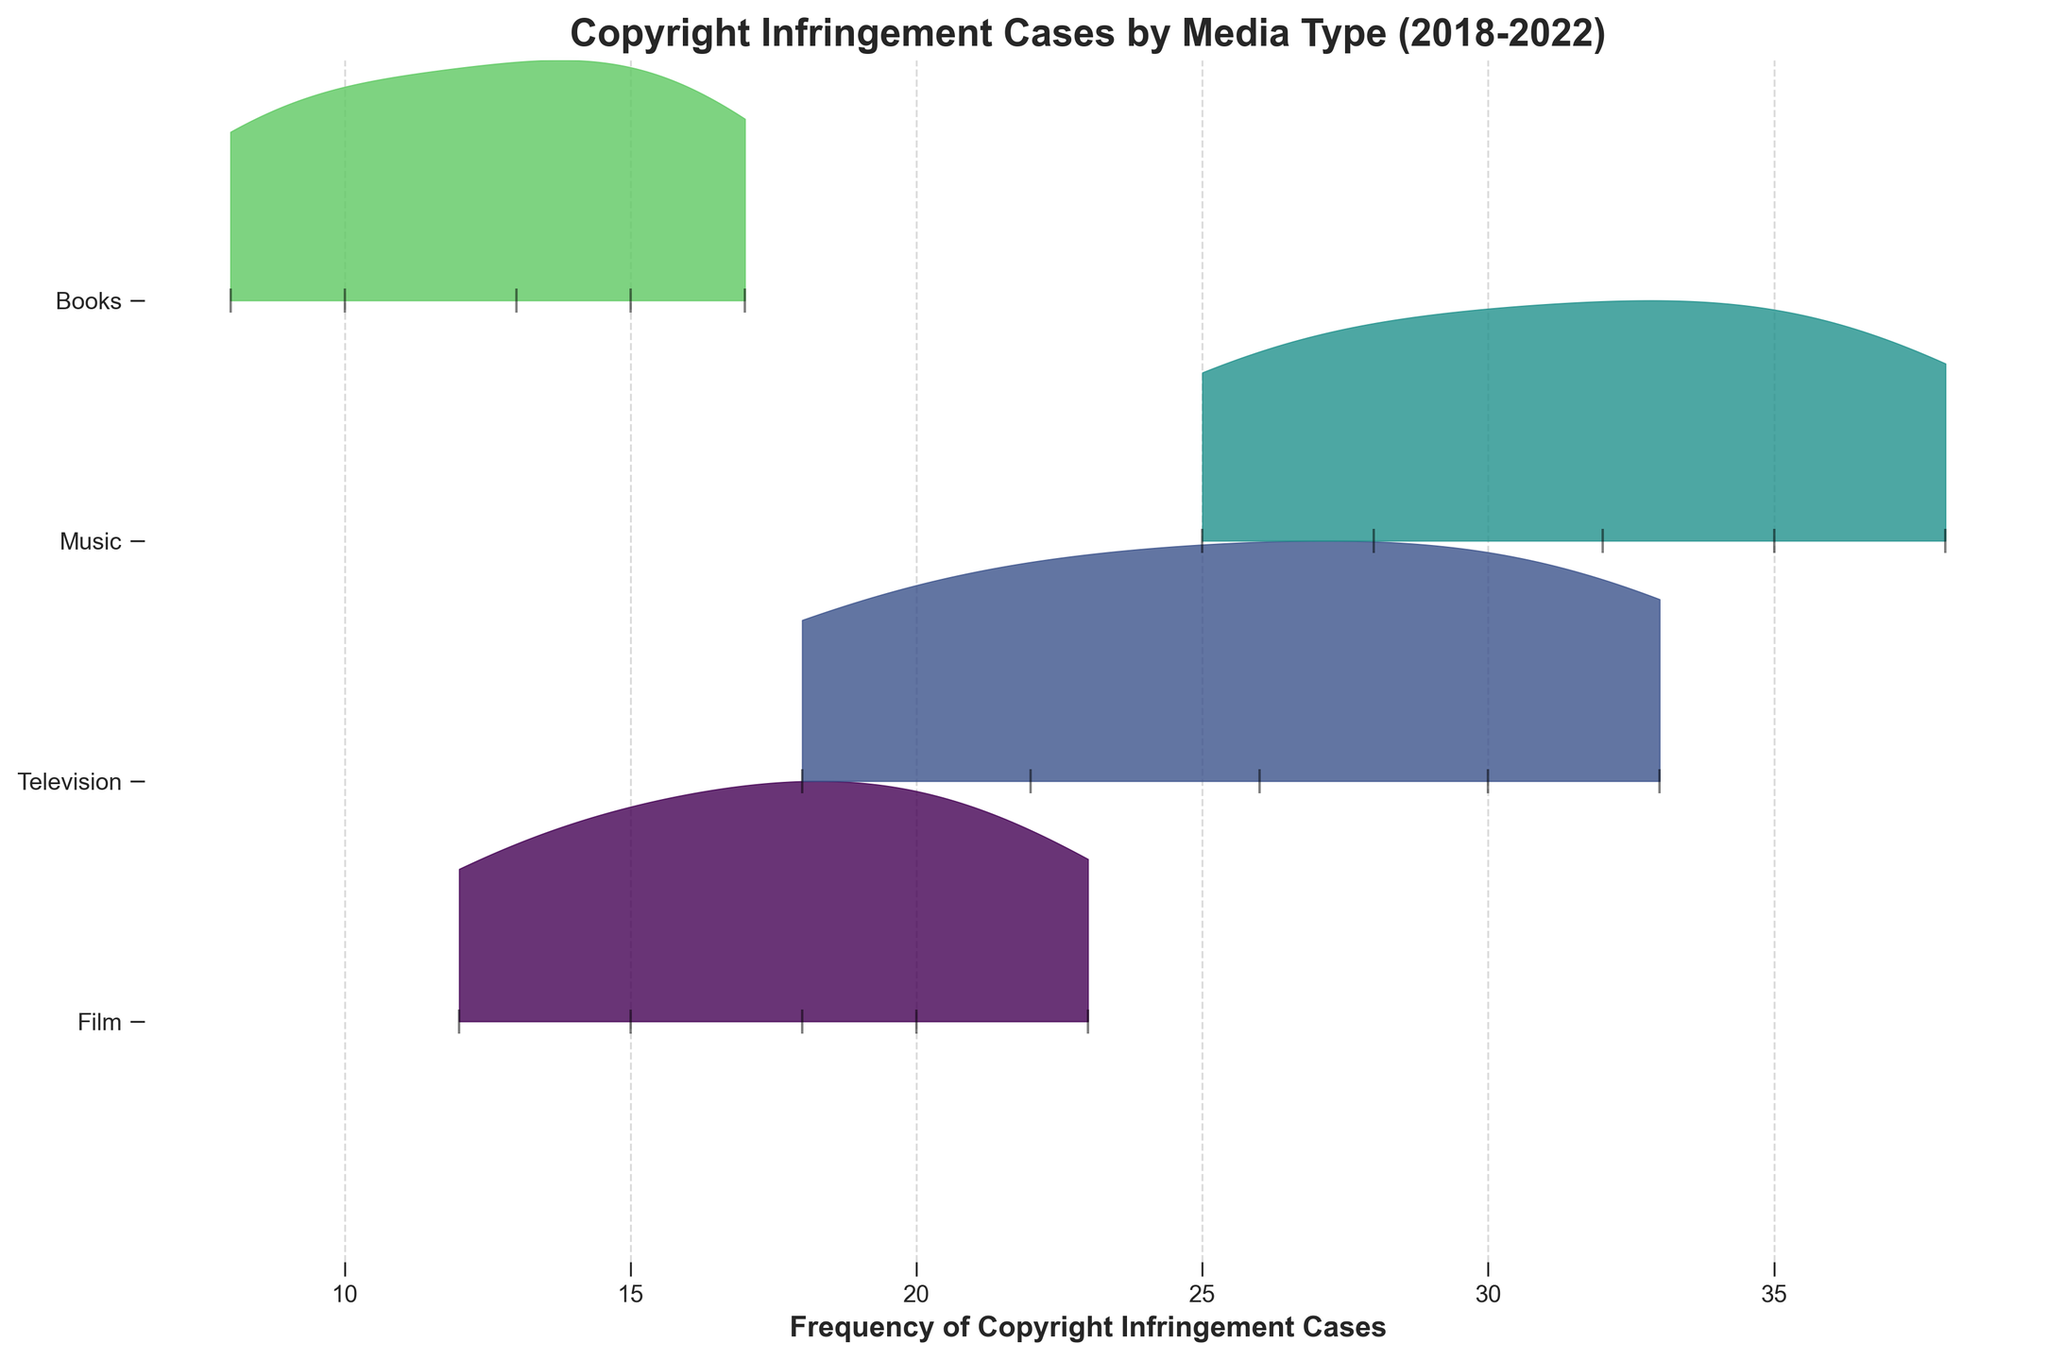How many different media types are represented in the plot? The title and axes labels indicate that the plot covers four different media types: Film, Television, Music, and Books. This is also evident from the four separate ridgelines in the plot.
Answer: 4 Which media type has the highest frequency of copyright infringement cases overall? By observing the heights of the ridgelines, we see that the Music category consistently appears at higher positions across all years, indicating higher frequency values overall.
Answer: Music How does the frequency of copyright infringement cases in television compare between 2018 and 2022? The plot shows that the frequency of cases in the Television category increased between 2018 (18 cases) and 2022 (33 cases), demonstrating an upward trend.
Answer: Increased Which media type saw the greatest increase in copyright infringement cases from 2018 to 2022? Comparing the ridgelines, Music shows the most significant increase in frequency from 25 cases in 2018 to 38 cases in 2022, which is an increase of 13 cases.
Answer: Music What is the range of the frequency of copyright infringement cases for films? The plot indicates that the frequencies for Film range from 12 in 2018 to 23 in 2022. This gives a range of 23 - 12 = 11.
Answer: 11 What is the trend of copyright infringement cases in books from 2018 to 2022? By observing the plot, we see a steady increase in Books' cases from 8 in 2018 to 17 in 2022, indicating a gradual upward trend.
Answer: Increasing In which year did the Music media type first reach a frequency of 30 or more copyright infringement cases? Referring to the ridgeline for Music, the frequency first exceeded 30 in the year 2020, where the frequency was 32.
Answer: 2020 Compare the density distribution of Film and Television ridgelines, which one shows a broader spread? Observing the width of the ridgelines, we can see that the Television category shows a broader spread, indicating a wider range of frequencies over the years compared to Film.
Answer: Television What is the maximum frequency value of copyright infringement cases observed for any media type and which media is it? The plot shows that the highest frequency value observed is for Music in 2022, with a frequency of 38 cases.
Answer: 38 Which media type shows the smallest change in the frequency of copyright infringement cases from 2018 to 2022? By examining the ridgelines, Books show the smallest change, increasing only by 9 cases from 8 in 2018 to 17 in 2022.
Answer: Books 